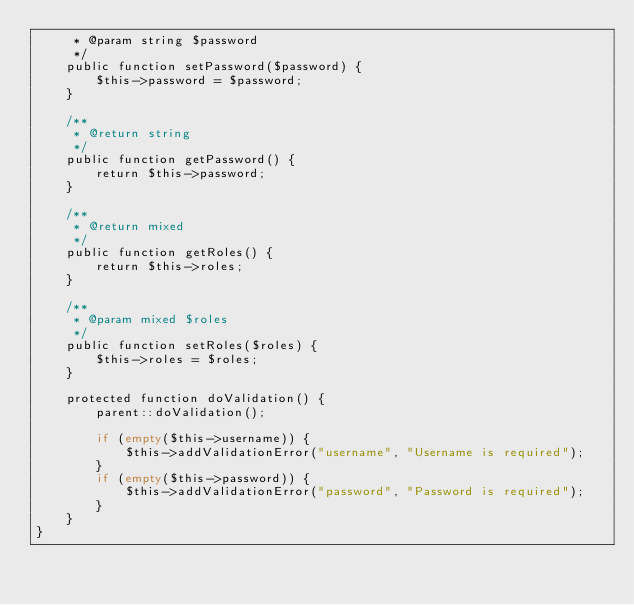Convert code to text. <code><loc_0><loc_0><loc_500><loc_500><_PHP_>     * @param string $password
     */
    public function setPassword($password) {
        $this->password = $password;
    }

    /**
     * @return string
     */
    public function getPassword() {
        return $this->password;
    }

    /**
     * @return mixed
     */
    public function getRoles() {
        return $this->roles;
    }

    /**
     * @param mixed $roles
     */
    public function setRoles($roles) {
        $this->roles = $roles;
    }

    protected function doValidation() {
        parent::doValidation();

        if (empty($this->username)) {
            $this->addValidationError("username", "Username is required");
        }
        if (empty($this->password)) {
            $this->addValidationError("password", "Password is required");
        }
    }
}</code> 